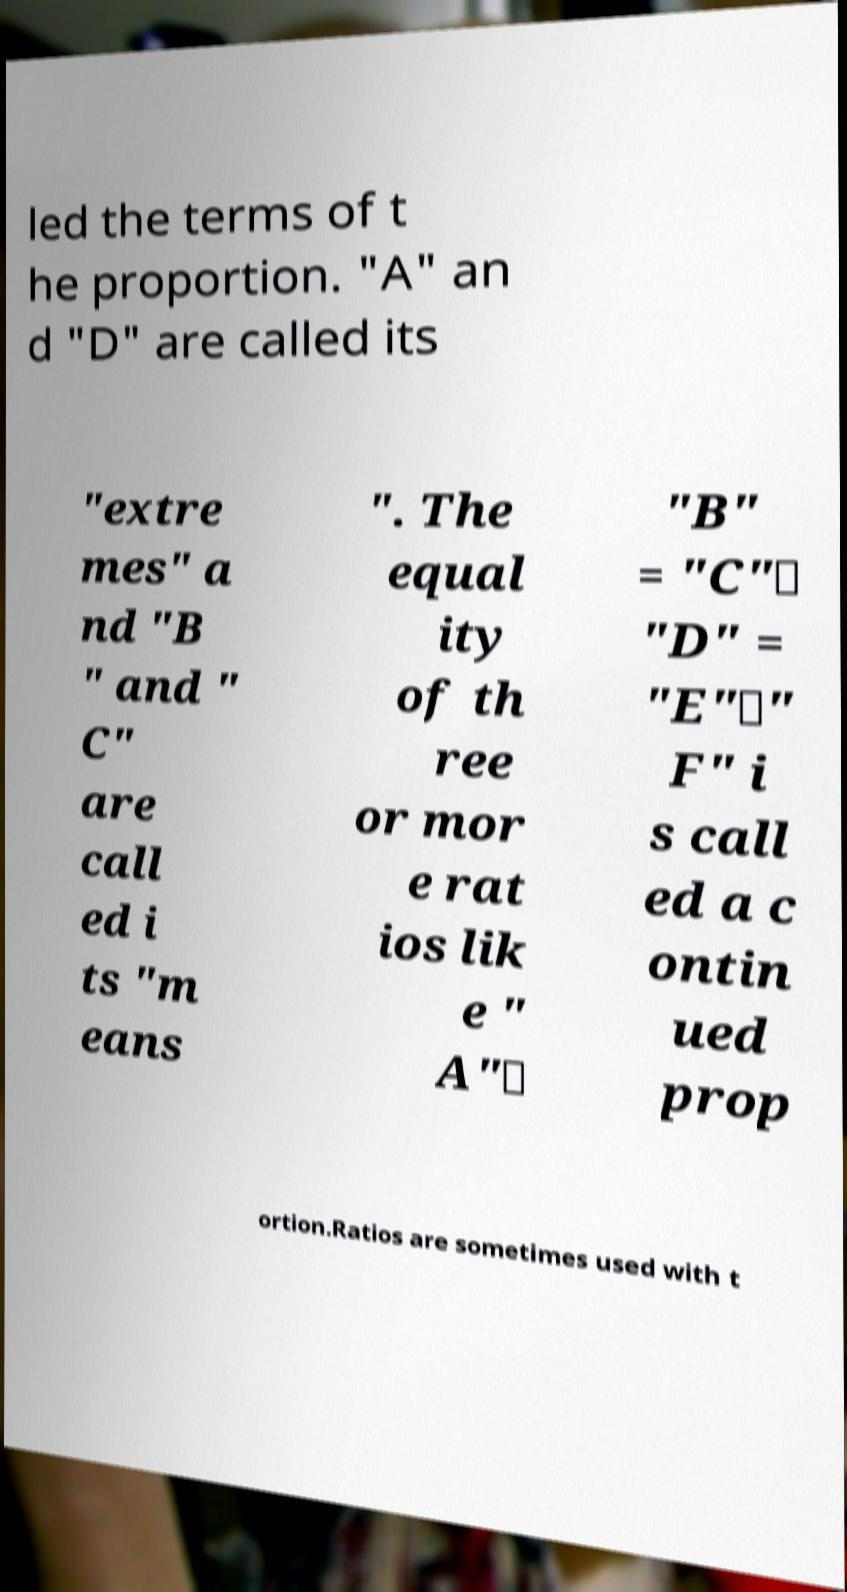Can you accurately transcribe the text from the provided image for me? led the terms of t he proportion. "A" an d "D" are called its "extre mes" a nd "B " and " C" are call ed i ts "m eans ". The equal ity of th ree or mor e rat ios lik e " A"∶ "B" = "C"∶ "D" = "E"∶" F" i s call ed a c ontin ued prop ortion.Ratios are sometimes used with t 